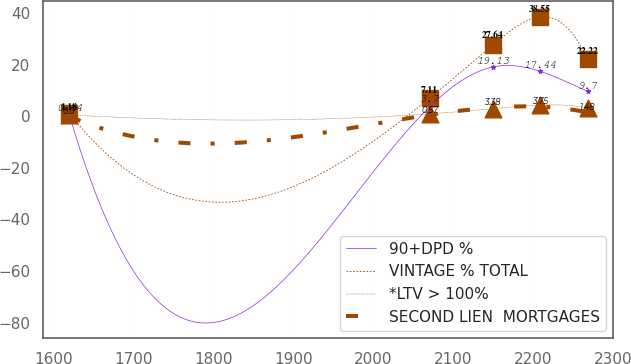Convert chart to OTSL. <chart><loc_0><loc_0><loc_500><loc_500><line_chart><ecel><fcel>90+DPD %<fcel>VINTAGE % TOTAL<fcel>*LTV > 100%<fcel>SECOND LIEN  MORTGAGES<nl><fcel>1619.55<fcel>0.64<fcel>1.18<fcel>0.58<fcel>0<nl><fcel>2070.33<fcel>3.7<fcel>7.11<fcel>0.96<fcel>0.57<nl><fcel>2149.28<fcel>19.13<fcel>27.64<fcel>2.94<fcel>3.38<nl><fcel>2208.51<fcel>17.44<fcel>38.55<fcel>4.36<fcel>3.75<nl><fcel>2267.74<fcel>9.7<fcel>22.22<fcel>3.32<fcel>1.48<nl></chart> 